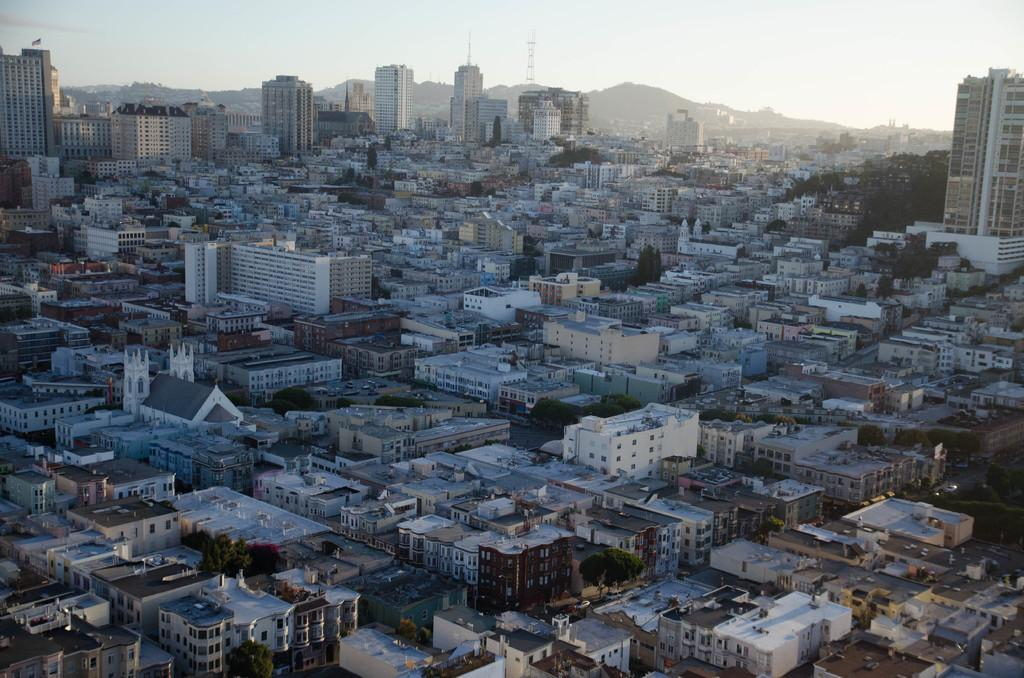What type of structures can be seen in the image? There are homes and buildings in the image. Can you describe the general layout of the structures? The image shows a mix of residential homes and other types of buildings, but it doesn't provide enough detail to describe the layout. What type of pleasure can be seen in the image? There is no indication of pleasure in the image; it simply shows homes and buildings. What type of spade is being used to dig in the image? There is no spade present in the image; it only shows homes and buildings. 